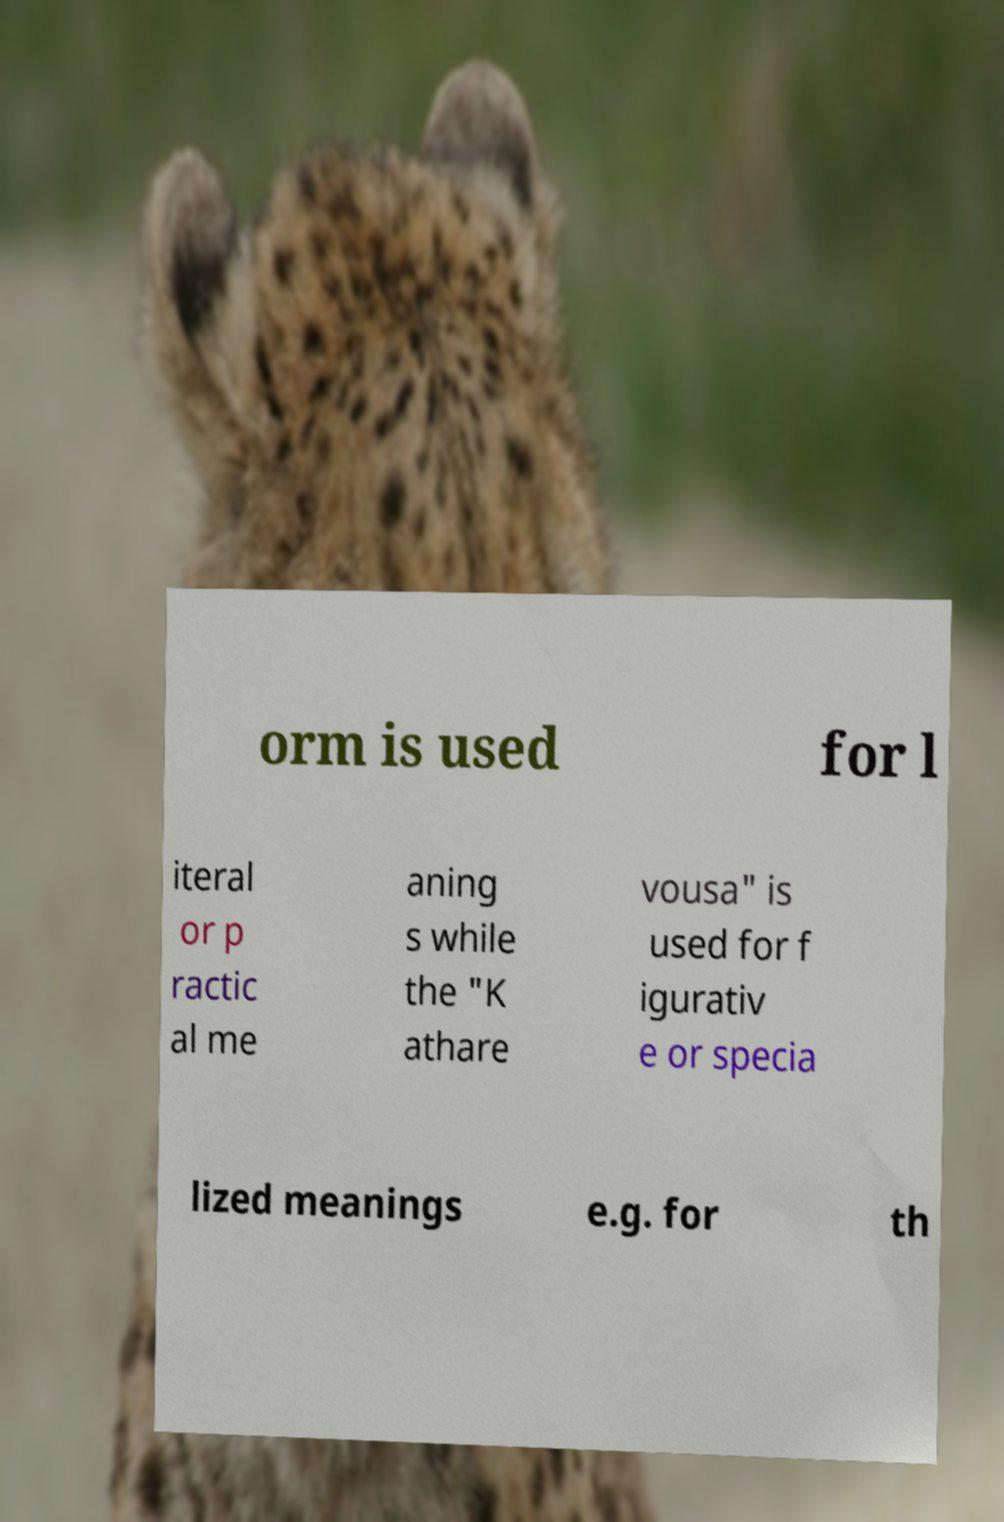Please identify and transcribe the text found in this image. orm is used for l iteral or p ractic al me aning s while the "K athare vousa" is used for f igurativ e or specia lized meanings e.g. for th 